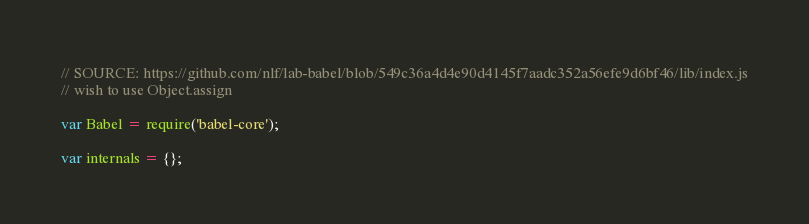<code> <loc_0><loc_0><loc_500><loc_500><_JavaScript_>// SOURCE: https://github.com/nlf/lab-babel/blob/549c36a4d4e90d4145f7aadc352a56efe9d6bf46/lib/index.js
// wish to use Object.assign

var Babel = require('babel-core');

var internals = {};</code> 